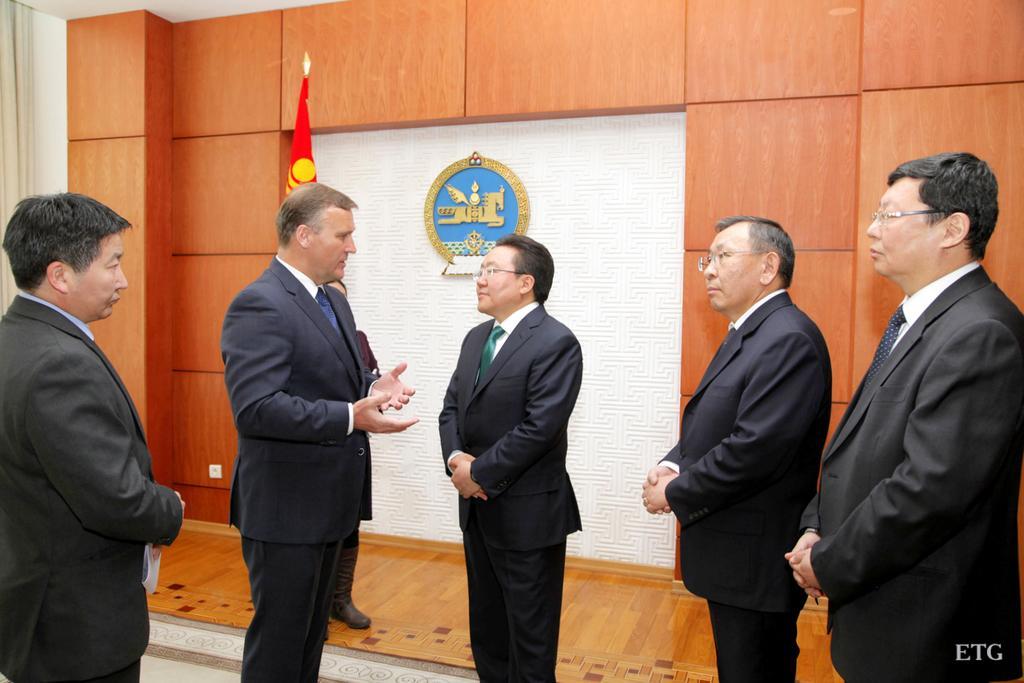Please provide a concise description of this image. There are people standing. Background we can see wall,curtain,flag and logo on white surface. 